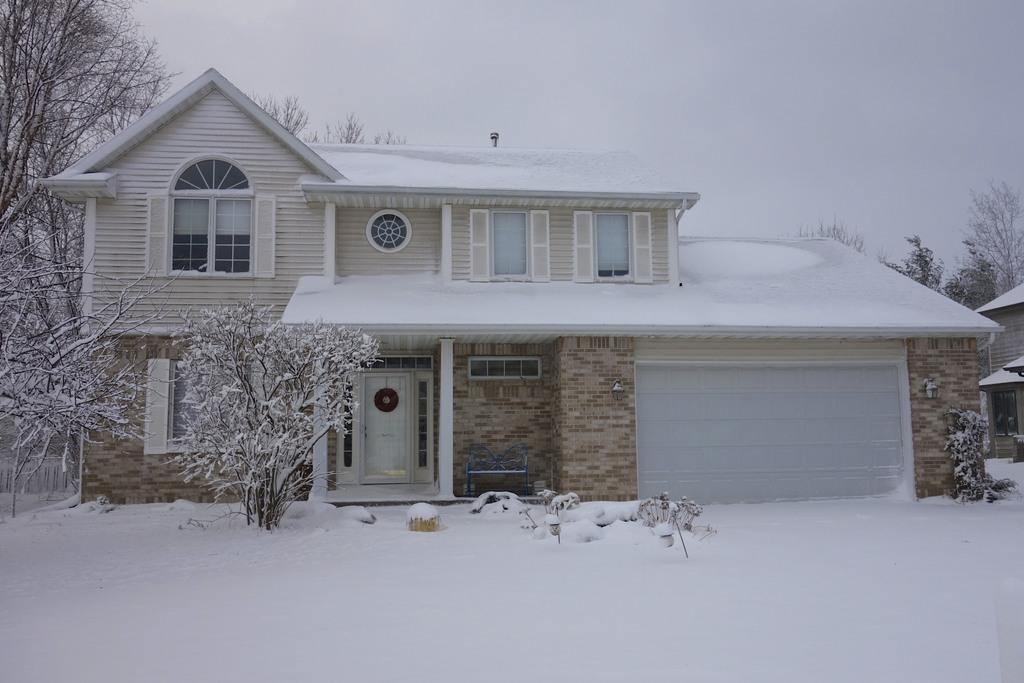Could you give a brief overview of what you see in this image? At the bottom of the image there is snow. In the middle of the image there are some plants and house. Behind them there are some trees. At the top of the image there is sky. 